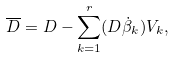Convert formula to latex. <formula><loc_0><loc_0><loc_500><loc_500>\overline { D } = D - \sum _ { k = 1 } ^ { r } ( D \dot { \beta } _ { k } ) V _ { k } ,</formula> 